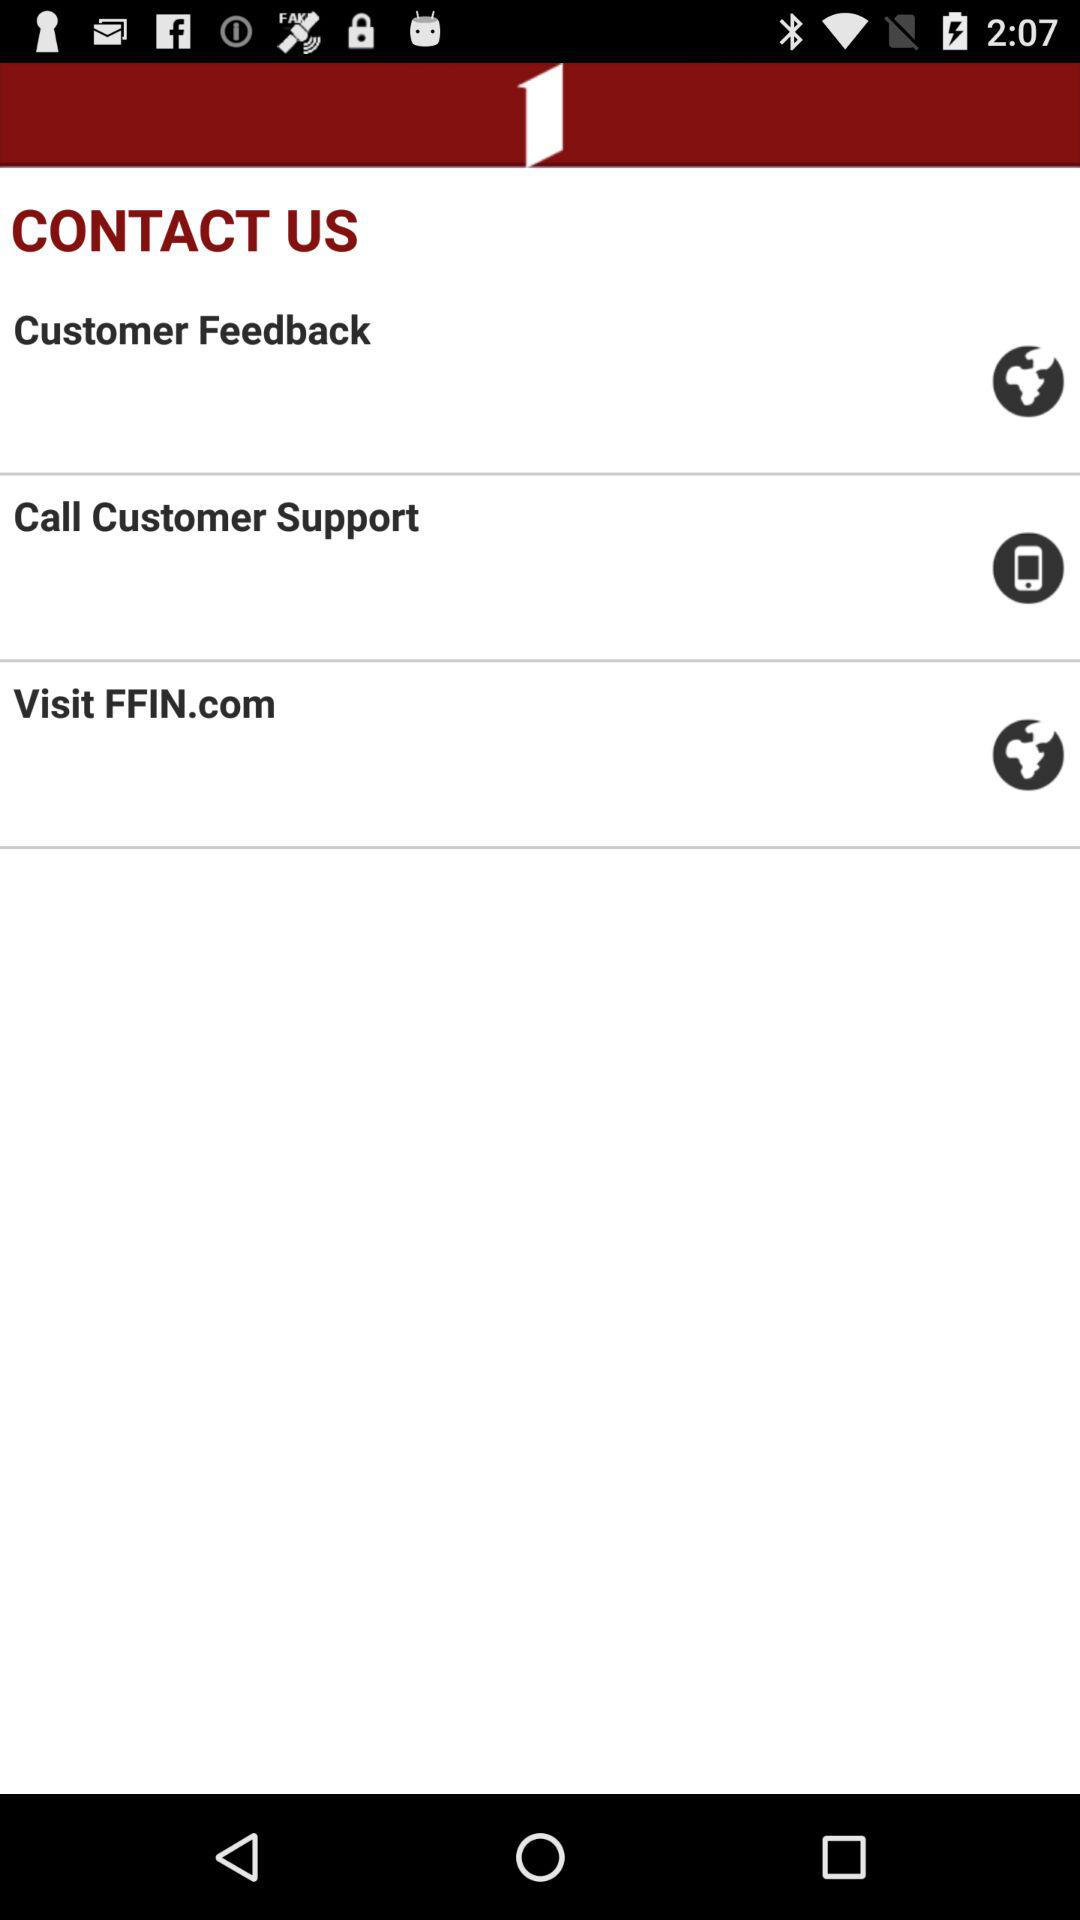How many contact us options are there?
Answer the question using a single word or phrase. 3 